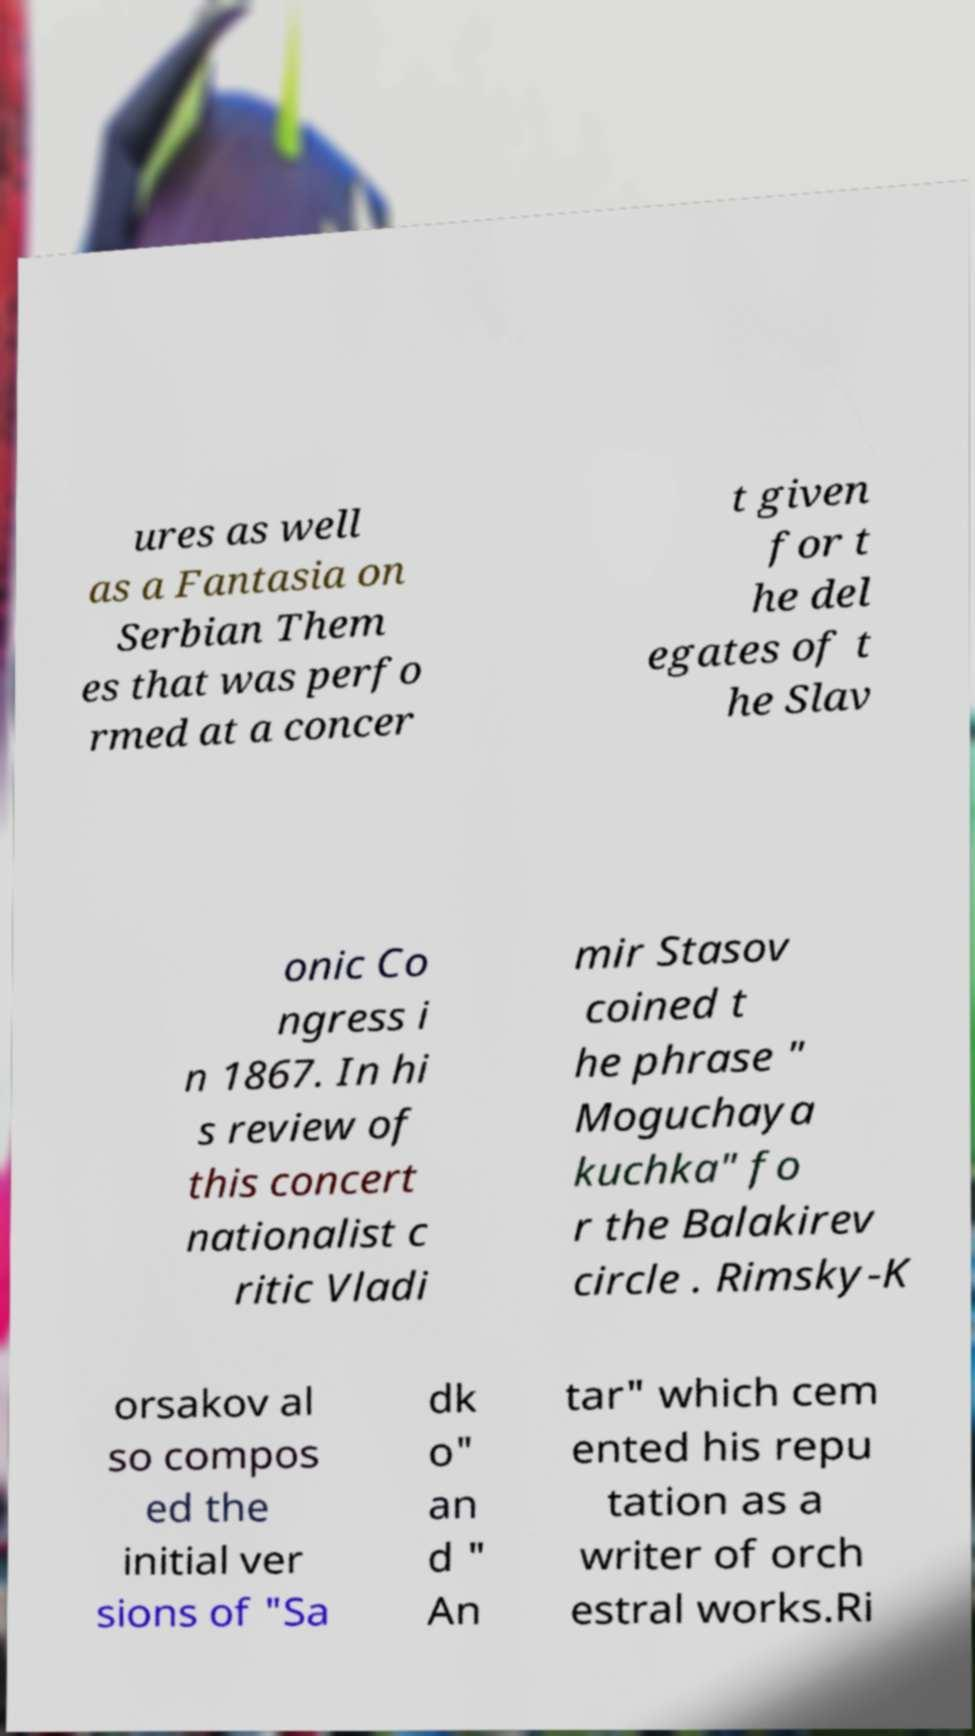Please identify and transcribe the text found in this image. ures as well as a Fantasia on Serbian Them es that was perfo rmed at a concer t given for t he del egates of t he Slav onic Co ngress i n 1867. In hi s review of this concert nationalist c ritic Vladi mir Stasov coined t he phrase " Moguchaya kuchka" fo r the Balakirev circle . Rimsky-K orsakov al so compos ed the initial ver sions of "Sa dk o" an d " An tar" which cem ented his repu tation as a writer of orch estral works.Ri 